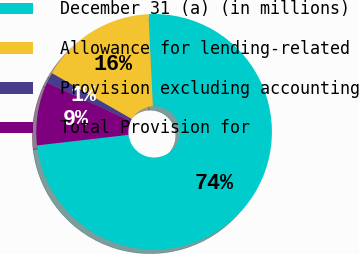<chart> <loc_0><loc_0><loc_500><loc_500><pie_chart><fcel>December 31 (a) (in millions)<fcel>Allowance for lending-related<fcel>Provision excluding accounting<fcel>Total Provision for<nl><fcel>73.93%<fcel>15.94%<fcel>1.44%<fcel>8.69%<nl></chart> 